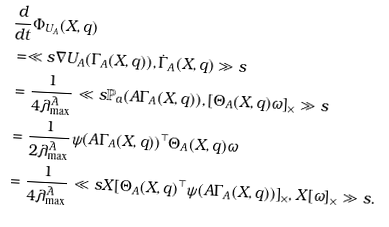Convert formula to latex. <formula><loc_0><loc_0><loc_500><loc_500>& \frac { d } { d t } \Phi _ { U _ { A } } ( X , q ) \\ & = \ll s \nabla U _ { A } ( \Gamma _ { A } ( X , q ) ) , \dot { \Gamma } _ { A } ( X , q ) \gg s \\ & = \frac { 1 } { 4 \lambda _ { \max } ^ { \bar { A } } } \ll s \mathbb { P } _ { a } ( A \Gamma _ { A } ( X , q ) ) , \left [ \Theta _ { A } ( X , q ) \omega \right ] _ { \times } \gg s \\ & = \frac { 1 } { 2 \lambda _ { \max } ^ { \bar { A } } } \psi ( A \Gamma _ { A } ( X , q ) ) ^ { \top } \Theta _ { A } ( X , q ) \omega \\ & = \frac { 1 } { 4 \lambda _ { \max } ^ { \bar { A } } } \ll s X [ \Theta _ { A } ( X , q ) ^ { \top } \psi ( A \Gamma _ { A } ( X , q ) ) ] _ { \times } , X [ \omega ] _ { \times } \gg s .</formula> 